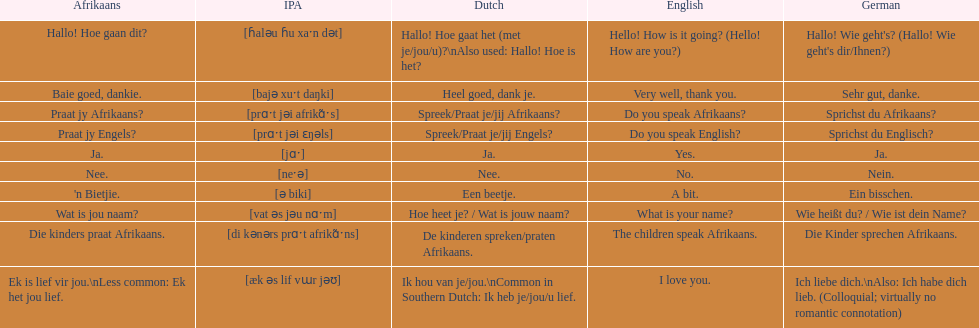Translate the following into german: die kinders praat afrikaans. Die Kinder sprechen Afrikaans. 